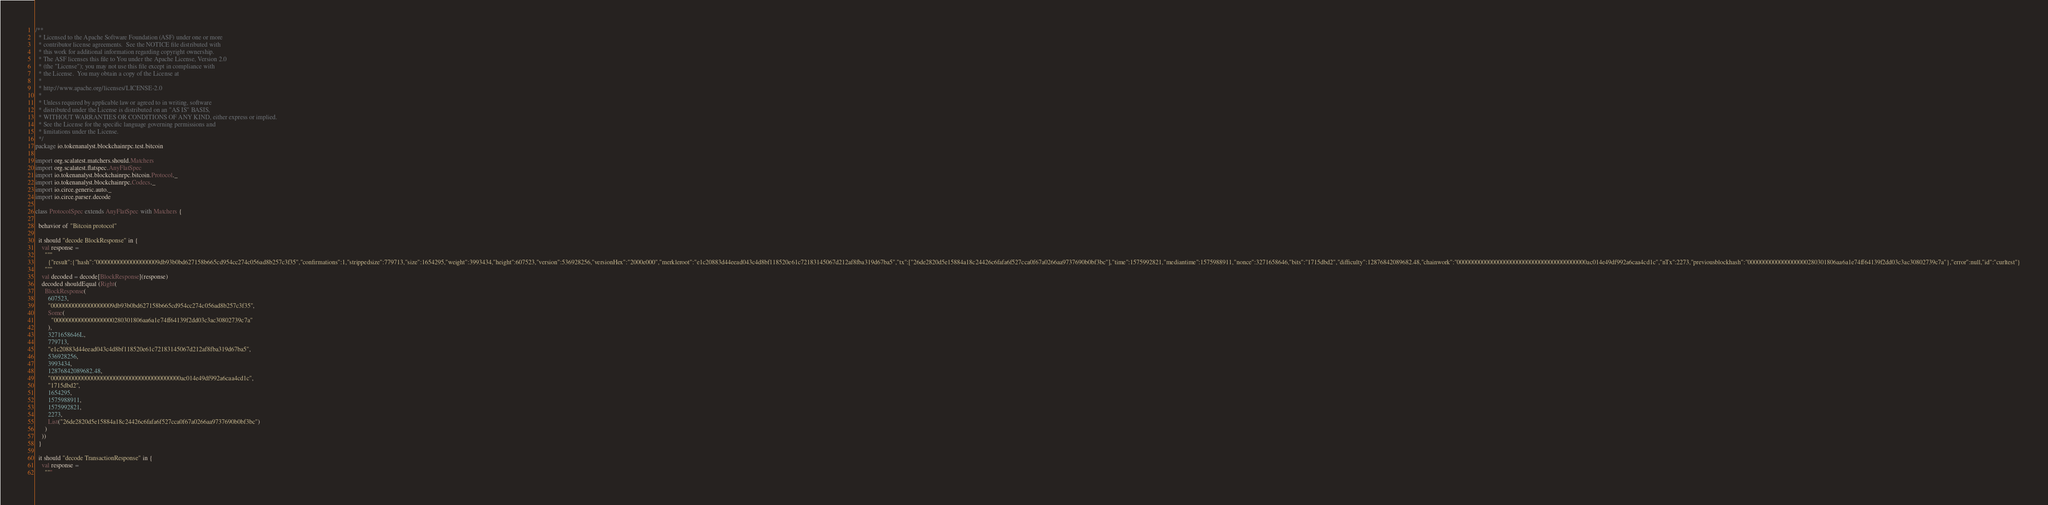<code> <loc_0><loc_0><loc_500><loc_500><_Scala_>/**
  * Licensed to the Apache Software Foundation (ASF) under one or more
  * contributor license agreements.  See the NOTICE file distributed with
  * this work for additional information regarding copyright ownership.
  * The ASF licenses this file to You under the Apache License, Version 2.0
  * (the "License"); you may not use this file except in compliance with
  * the License.  You may obtain a copy of the License at
  *
  * http://www.apache.org/licenses/LICENSE-2.0
  *
  * Unless required by applicable law or agreed to in writing, software
  * distributed under the License is distributed on an "AS IS" BASIS,
  * WITHOUT WARRANTIES OR CONDITIONS OF ANY KIND, either express or implied.
  * See the License for the specific language governing permissions and
  * limitations under the License.
  */
package io.tokenanalyst.blockchainrpc.test.bitcoin

import org.scalatest.matchers.should.Matchers
import org.scalatest.flatspec.AnyFlatSpec
import io.tokenanalyst.blockchainrpc.bitcoin.Protocol._
import io.tokenanalyst.blockchainrpc.Codecs._
import io.circe.generic.auto._
import io.circe.parser.decode

class ProtocolSpec extends AnyFlatSpec with Matchers {

  behavior of "Bitcoin protocol"

  it should "decode BlockResponse" in {
    val response =
      """
        {"result":{"hash":"00000000000000000009db93b0bd627158b665cd954cc274c056ad8b257c3f35","confirmations":1,"strippedsize":779713,"size":1654295,"weight":3993434,"height":607523,"version":536928256,"versionHex":"2000e000","merkleroot":"e1c20883d44eead043c4d8bf118520e61c72183145067d212af8fba319d67ba5","tx":["26de2820d5e15884a18c24426c6fafa6f527cca0f67a0266aa9737690b0bf3bc"],"time":1575992821,"mediantime":1575988911,"nonce":3271658646,"bits":"1715dbd2","difficulty":12876842089682.48,"chainwork":"00000000000000000000000000000000000000000ac014e49df992a6caa4cd1c","nTx":2273,"previousblockhash":"0000000000000000000280301806aa6a1e74ff64139f2dd03c3ac30802739c7a"},"error":null,"id":"curltest"}
      """
    val decoded = decode[BlockResponse](response)
    decoded shouldEqual (Right(
      BlockResponse(
        607523,
        "00000000000000000009db93b0bd627158b665cd954cc274c056ad8b257c3f35",
        Some(
          "0000000000000000000280301806aa6a1e74ff64139f2dd03c3ac30802739c7a"
        ),
        3271658646L,
        779713,
        "e1c20883d44eead043c4d8bf118520e61c72183145067d212af8fba319d67ba5",
        536928256,
        3993434,
        12876842089682.48,
        "00000000000000000000000000000000000000000ac014e49df992a6caa4cd1c",
        "1715dbd2",
        1654295,
        1575988911,
        1575992821,
        2273,
        List("26de2820d5e15884a18c24426c6fafa6f527cca0f67a0266aa9737690b0bf3bc")
      )
    ))
  }

  it should "decode TransactionResponse" in {
    val response =
      """</code> 